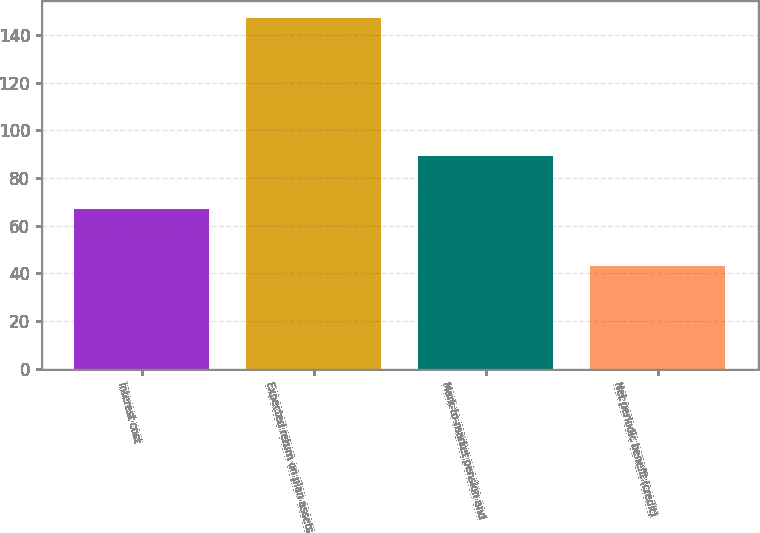<chart> <loc_0><loc_0><loc_500><loc_500><bar_chart><fcel>Interest cost<fcel>Expected return on plan assets<fcel>Mark-to-market pension and<fcel>Net periodic benefit (credit)<nl><fcel>67<fcel>147<fcel>89<fcel>43<nl></chart> 